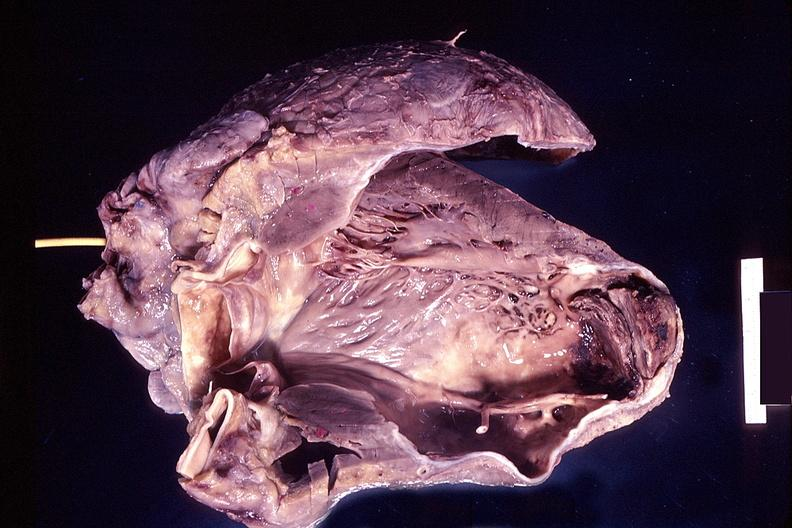what does this image show?
Answer the question using a single word or phrase. Heart 